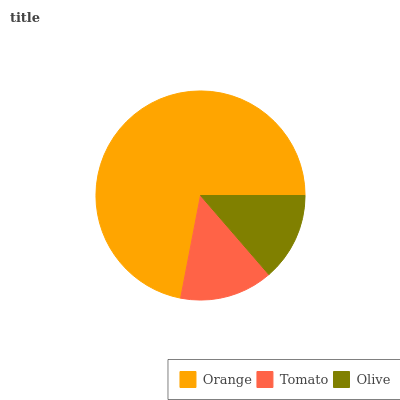Is Olive the minimum?
Answer yes or no. Yes. Is Orange the maximum?
Answer yes or no. Yes. Is Tomato the minimum?
Answer yes or no. No. Is Tomato the maximum?
Answer yes or no. No. Is Orange greater than Tomato?
Answer yes or no. Yes. Is Tomato less than Orange?
Answer yes or no. Yes. Is Tomato greater than Orange?
Answer yes or no. No. Is Orange less than Tomato?
Answer yes or no. No. Is Tomato the high median?
Answer yes or no. Yes. Is Tomato the low median?
Answer yes or no. Yes. Is Orange the high median?
Answer yes or no. No. Is Orange the low median?
Answer yes or no. No. 